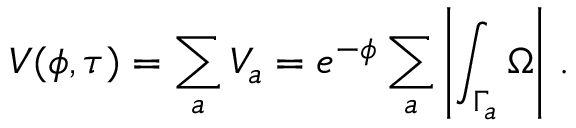<formula> <loc_0><loc_0><loc_500><loc_500>V ( \phi , \tau ) = \sum _ { a } V _ { a } = e ^ { - \phi } \sum _ { a } \left | \int _ { \Gamma _ { a } } \Omega \right | \, .</formula> 